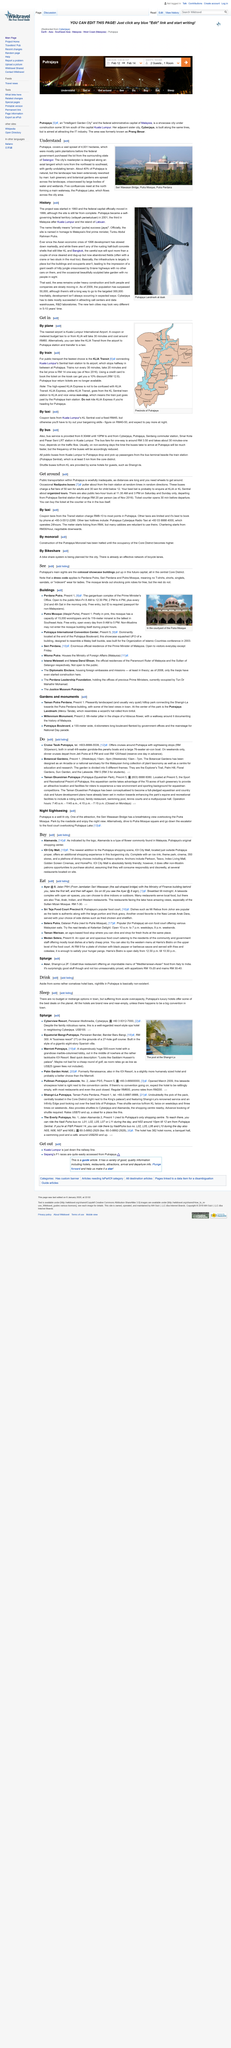List a handful of essential elements in this visual. The accompanying photo was taken in Putrajaya. The Seri Wawasan Bridge is the name of the bridge in the photograph. Approximately 40% of Putrajaya is kept in its natural state, reflecting the city's commitment to preserving its environment and maintaining a harmonious relationship with nature. 